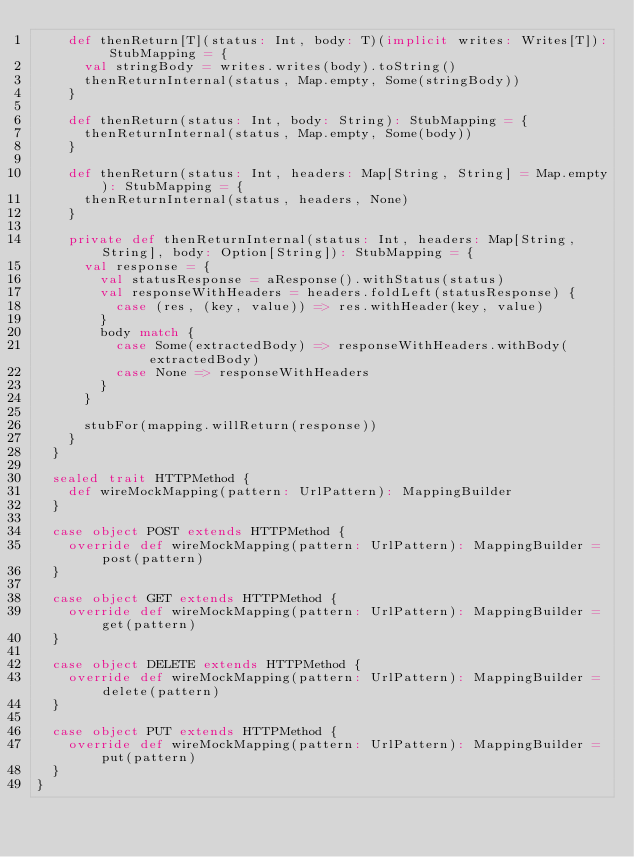<code> <loc_0><loc_0><loc_500><loc_500><_Scala_>    def thenReturn[T](status: Int, body: T)(implicit writes: Writes[T]): StubMapping = {
      val stringBody = writes.writes(body).toString()
      thenReturnInternal(status, Map.empty, Some(stringBody))
    }

    def thenReturn(status: Int, body: String): StubMapping = {
      thenReturnInternal(status, Map.empty, Some(body))
    }

    def thenReturn(status: Int, headers: Map[String, String] = Map.empty): StubMapping = {
      thenReturnInternal(status, headers, None)
    }

    private def thenReturnInternal(status: Int, headers: Map[String, String], body: Option[String]): StubMapping = {
      val response = {
        val statusResponse = aResponse().withStatus(status)
        val responseWithHeaders = headers.foldLeft(statusResponse) {
          case (res, (key, value)) => res.withHeader(key, value)
        }
        body match {
          case Some(extractedBody) => responseWithHeaders.withBody(extractedBody)
          case None => responseWithHeaders
        }
      }

      stubFor(mapping.willReturn(response))
    }
  }

  sealed trait HTTPMethod {
    def wireMockMapping(pattern: UrlPattern): MappingBuilder
  }

  case object POST extends HTTPMethod {
    override def wireMockMapping(pattern: UrlPattern): MappingBuilder = post(pattern)
  }

  case object GET extends HTTPMethod {
    override def wireMockMapping(pattern: UrlPattern): MappingBuilder = get(pattern)
  }

  case object DELETE extends HTTPMethod {
    override def wireMockMapping(pattern: UrlPattern): MappingBuilder = delete(pattern)
  }

  case object PUT extends HTTPMethod {
    override def wireMockMapping(pattern: UrlPattern): MappingBuilder = put(pattern)
  }
}
</code> 